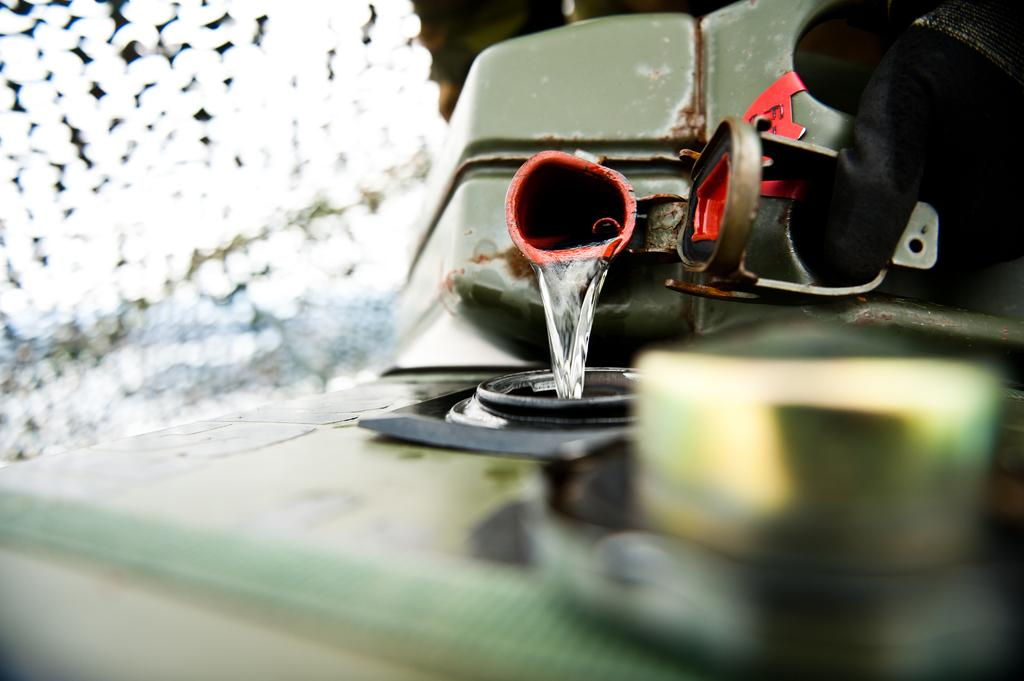What is being held by the person's hand in the image? There is a person's hand holding a container with water in the top right corner of the image. Can you describe the other container in the image? There is another container at the bottom of the image. What type of story is being told by the ground in the image? There is no story being told by the ground in the image, as it is not a subject capable of telling a story. 